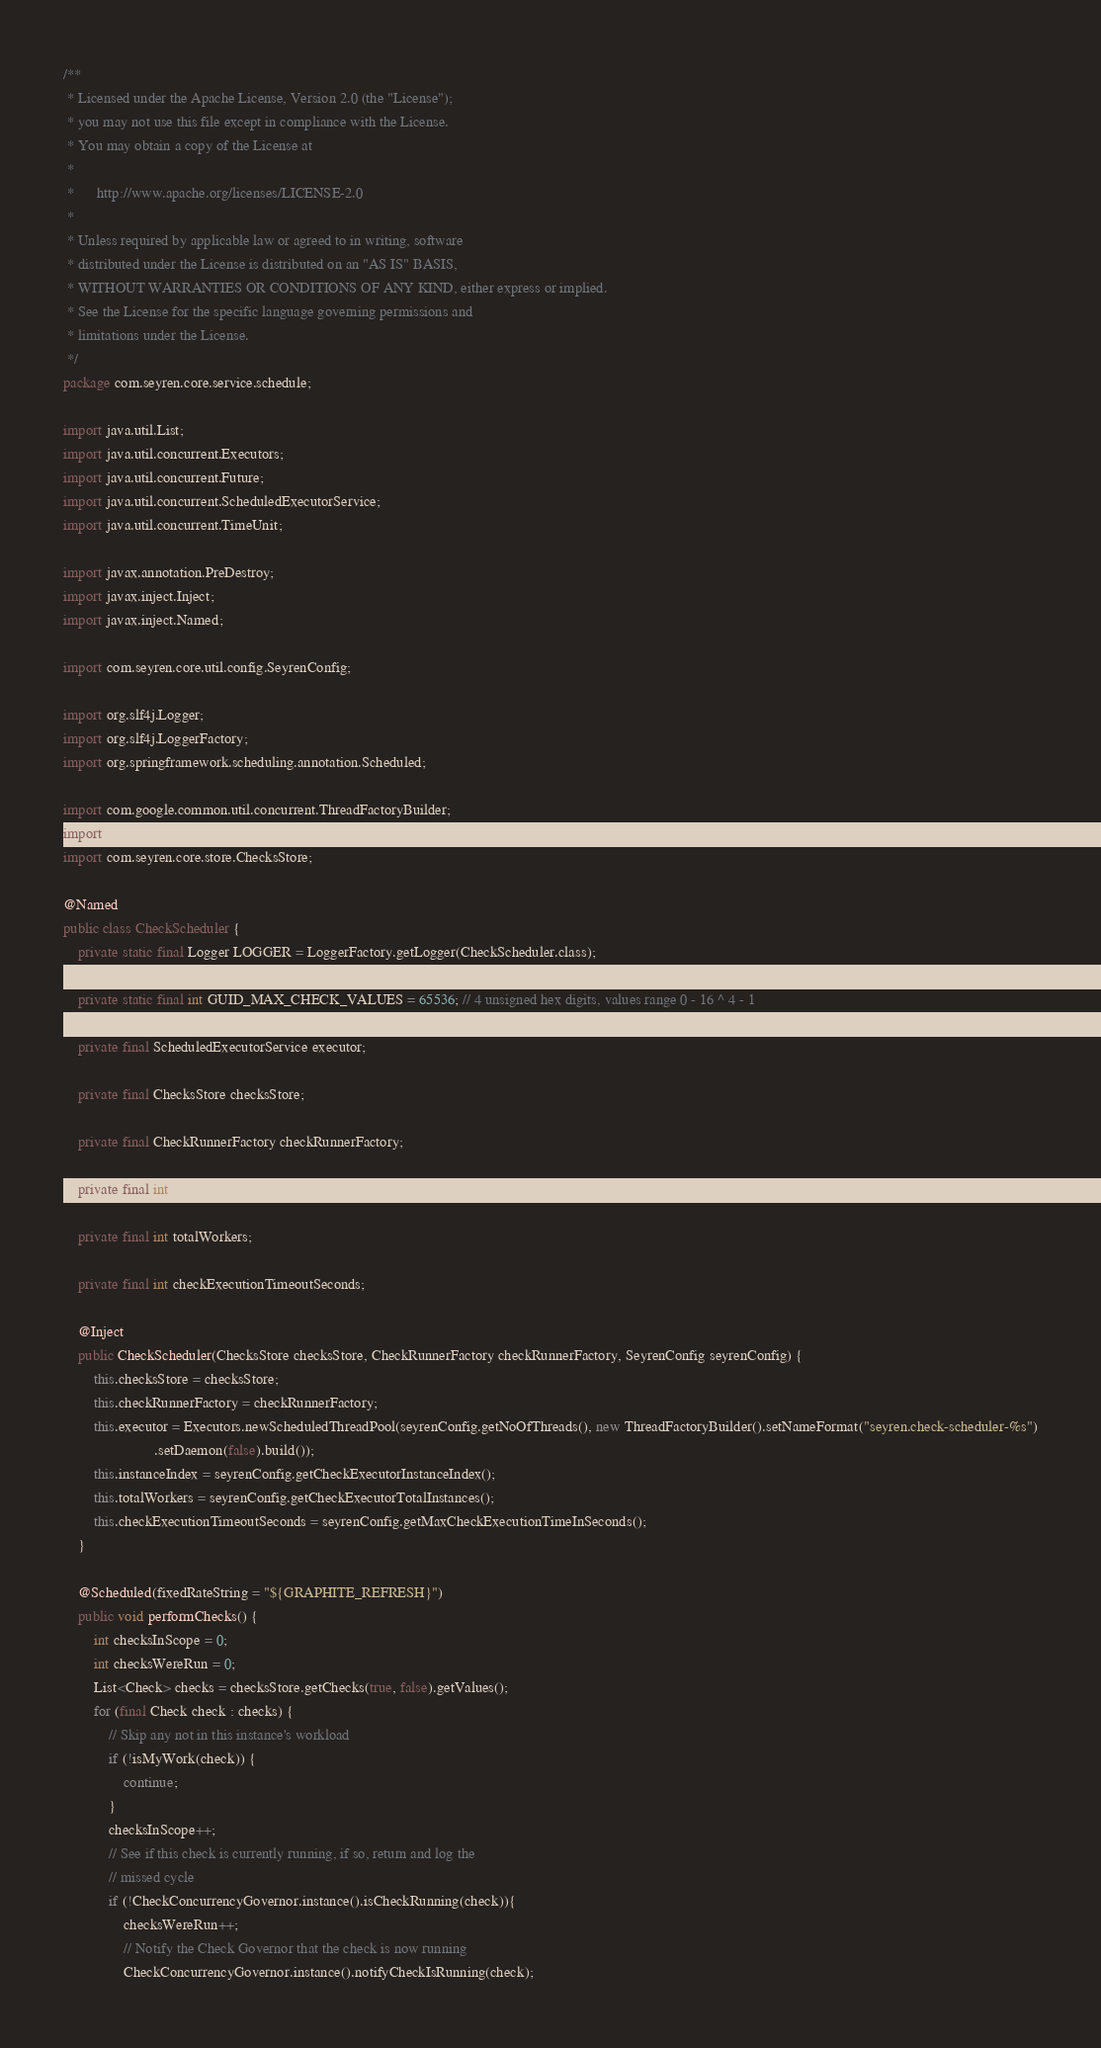Convert code to text. <code><loc_0><loc_0><loc_500><loc_500><_Java_>/**
 * Licensed under the Apache License, Version 2.0 (the "License");
 * you may not use this file except in compliance with the License.
 * You may obtain a copy of the License at
 *
 *      http://www.apache.org/licenses/LICENSE-2.0
 *
 * Unless required by applicable law or agreed to in writing, software
 * distributed under the License is distributed on an "AS IS" BASIS,
 * WITHOUT WARRANTIES OR CONDITIONS OF ANY KIND, either express or implied.
 * See the License for the specific language governing permissions and
 * limitations under the License.
 */
package com.seyren.core.service.schedule;

import java.util.List;
import java.util.concurrent.Executors;
import java.util.concurrent.Future;
import java.util.concurrent.ScheduledExecutorService;
import java.util.concurrent.TimeUnit;

import javax.annotation.PreDestroy;
import javax.inject.Inject;
import javax.inject.Named;

import com.seyren.core.util.config.SeyrenConfig;

import org.slf4j.Logger;
import org.slf4j.LoggerFactory;
import org.springframework.scheduling.annotation.Scheduled;

import com.google.common.util.concurrent.ThreadFactoryBuilder;
import com.seyren.core.domain.Check;
import com.seyren.core.store.ChecksStore;

@Named
public class CheckScheduler {
    private static final Logger LOGGER = LoggerFactory.getLogger(CheckScheduler.class);

    private static final int GUID_MAX_CHECK_VALUES = 65536; // 4 unsigned hex digits, values range 0 - 16 ^ 4 - 1

    private final ScheduledExecutorService executor;

    private final ChecksStore checksStore;

    private final CheckRunnerFactory checkRunnerFactory;

    private final int instanceIndex;

    private final int totalWorkers;

    private final int checkExecutionTimeoutSeconds;

    @Inject
    public CheckScheduler(ChecksStore checksStore, CheckRunnerFactory checkRunnerFactory, SeyrenConfig seyrenConfig) {
        this.checksStore = checksStore;
        this.checkRunnerFactory = checkRunnerFactory;
        this.executor = Executors.newScheduledThreadPool(seyrenConfig.getNoOfThreads(), new ThreadFactoryBuilder().setNameFormat("seyren.check-scheduler-%s")
                        .setDaemon(false).build());
        this.instanceIndex = seyrenConfig.getCheckExecutorInstanceIndex();
        this.totalWorkers = seyrenConfig.getCheckExecutorTotalInstances();
        this.checkExecutionTimeoutSeconds = seyrenConfig.getMaxCheckExecutionTimeInSeconds();
    }

    @Scheduled(fixedRateString = "${GRAPHITE_REFRESH}")
    public void performChecks() {
    	int checksInScope = 0;
    	int checksWereRun = 0;
        List<Check> checks = checksStore.getChecks(true, false).getValues();
        for (final Check check : checks) {
    		// Skip any not in this instance's workload
        	if (!isMyWork(check)) {
        		continue;
        	}
        	checksInScope++;
        	// See if this check is currently running, if so, return and log the
        	// missed cycle
        	if (!CheckConcurrencyGovernor.instance().isCheckRunning(check)){
        		checksWereRun++;
            	// Notify the Check Governor that the check is now running
            	CheckConcurrencyGovernor.instance().notifyCheckIsRunning(check);</code> 